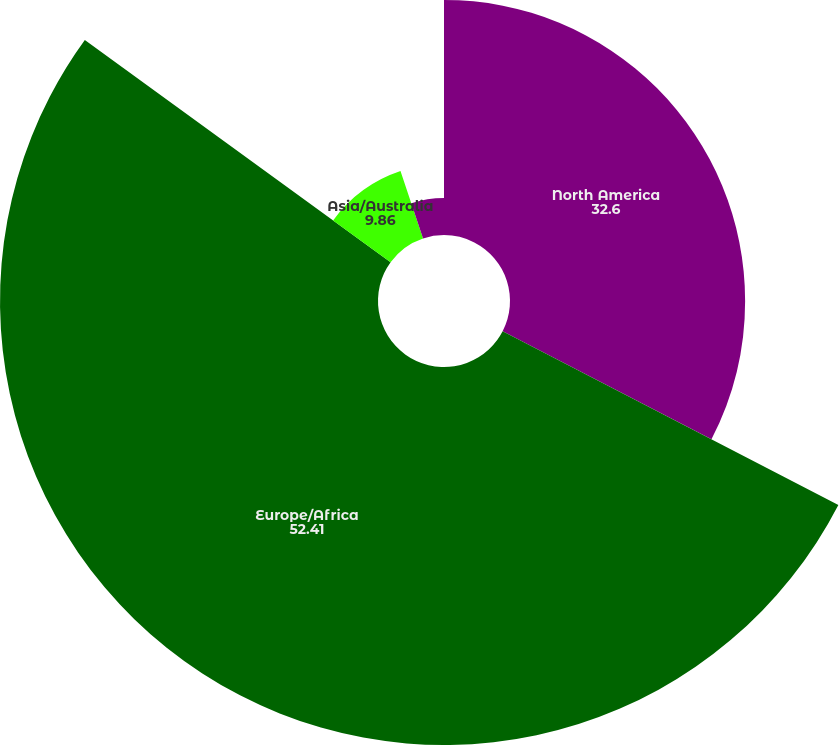Convert chart. <chart><loc_0><loc_0><loc_500><loc_500><pie_chart><fcel>North America<fcel>Europe/Africa<fcel>Asia/Australia<fcel>Rest of World<nl><fcel>32.6%<fcel>52.41%<fcel>9.86%<fcel>5.14%<nl></chart> 